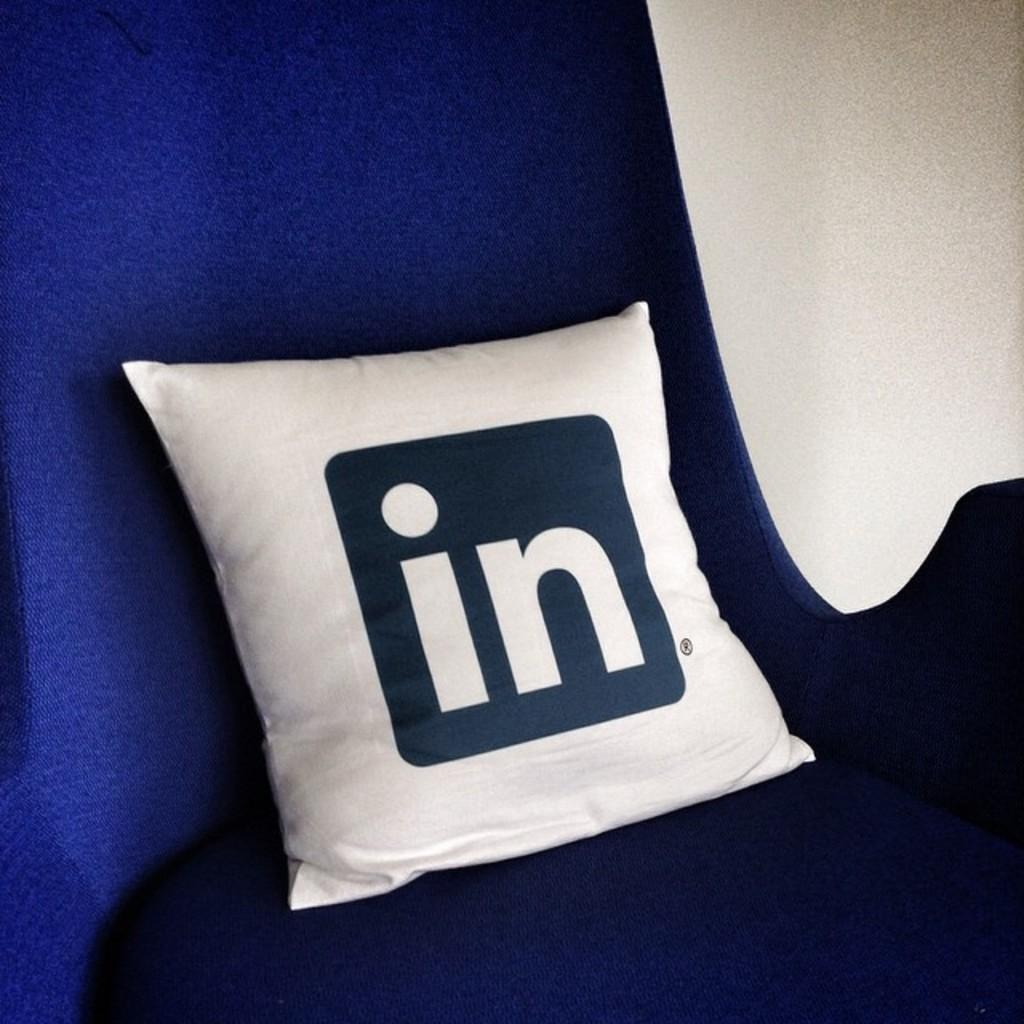Where was the image taken? The image is taken indoors. What can be seen in the background of the image? There is a wall in the background of the image. What is the main subject in the middle of the image? There is a pillow with text on it in the middle of the image. On what piece of furniture is the pillow placed? The pillow is on a couch. What type of meat is hanging from the ceiling in the image? There is no meat hanging from the ceiling in the image; it features a pillow with text on a couch. What kind of creature can be seen flying in the room in the image? There is no creature visible in the image; it only shows a pillow with text on a couch in an indoor setting. 